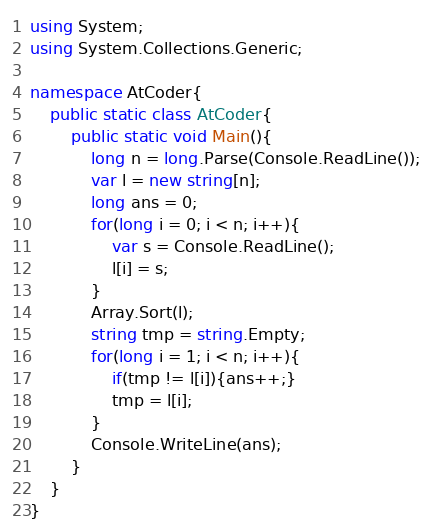Convert code to text. <code><loc_0><loc_0><loc_500><loc_500><_C#_>using System;
using System.Collections.Generic;

namespace AtCoder{
    public static class AtCoder{
        public static void Main(){
            long n = long.Parse(Console.ReadLine());
            var l = new string[n];
            long ans = 0;
            for(long i = 0; i < n; i++){
                var s = Console.ReadLine();
                l[i] = s;
            }
            Array.Sort(l);
            string tmp = string.Empty;
            for(long i = 1; i < n; i++){
                if(tmp != l[i]){ans++;}
                tmp = l[i];
            }
            Console.WriteLine(ans);
        }
    }
}</code> 